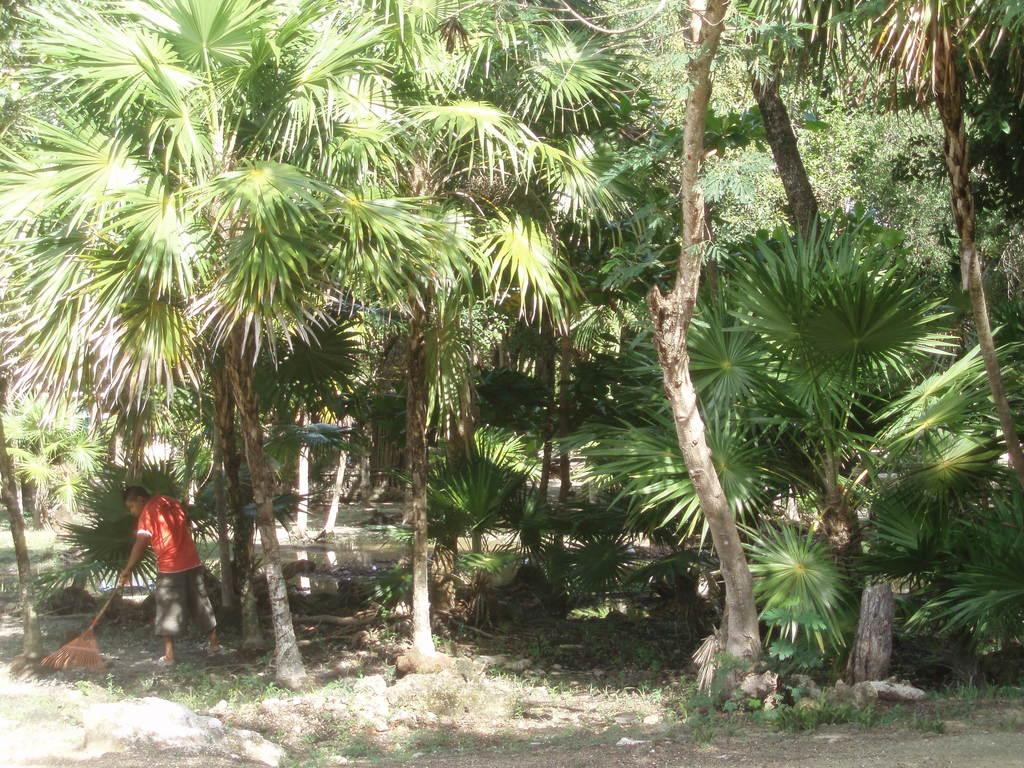What is the main subject of the image? There is a person in the image. What is the person doing in the image? The person is sweeping the ground. What can be seen in the background of the image? There is water and trees visible in the background of the image. What type of quiver can be seen on the person's back in the image? There is no quiver present on the person's back in the image. What smell is associated with the person in the image? There is no information about smells in the image, so it cannot be determined. 